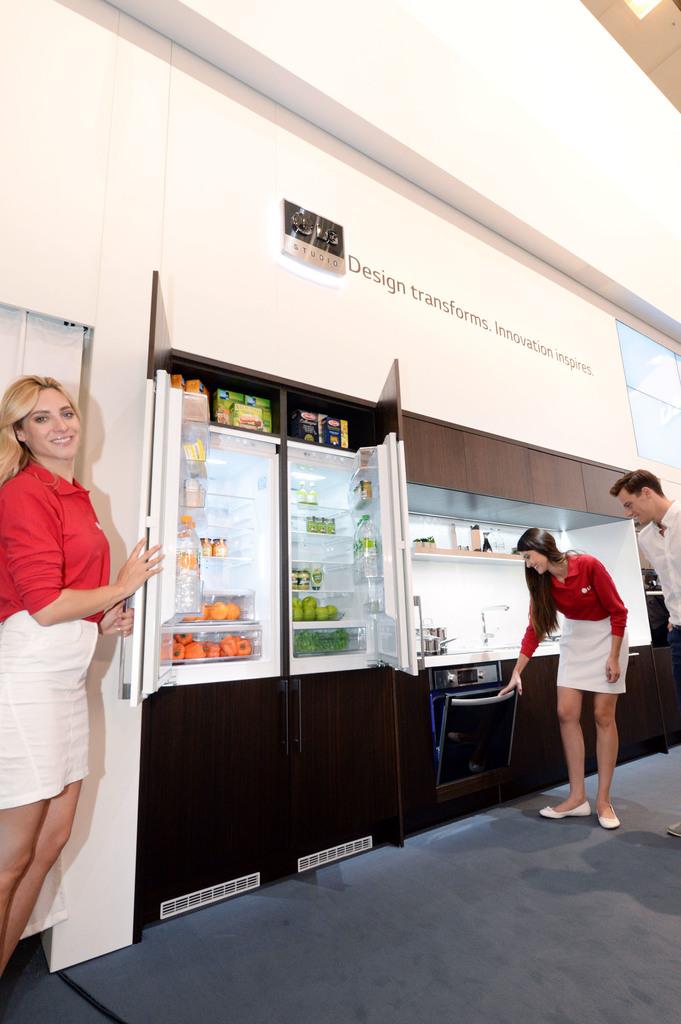What is the slogan at the top?
Keep it short and to the point. Design transforms. innovation inspires. 